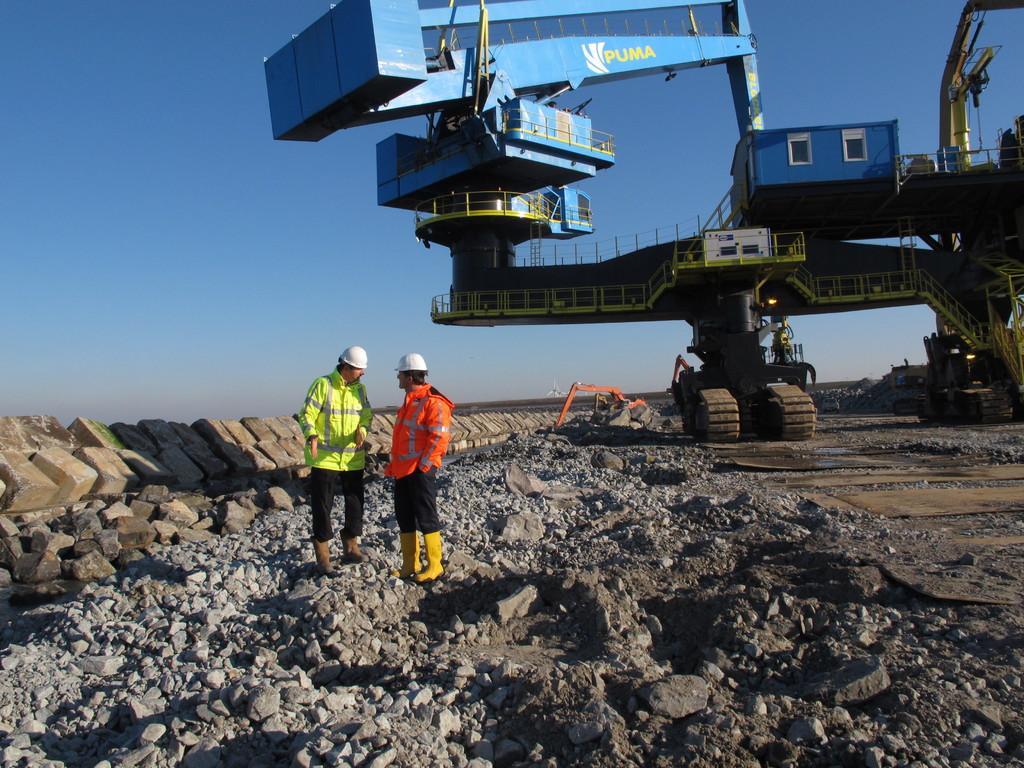Describe this image in one or two sentences. In the foreground of this image, there are stones and two men standing on it. On the left, there is a small stone wall. On the right, there is a crane. In the background, there is another crane and the sky. 